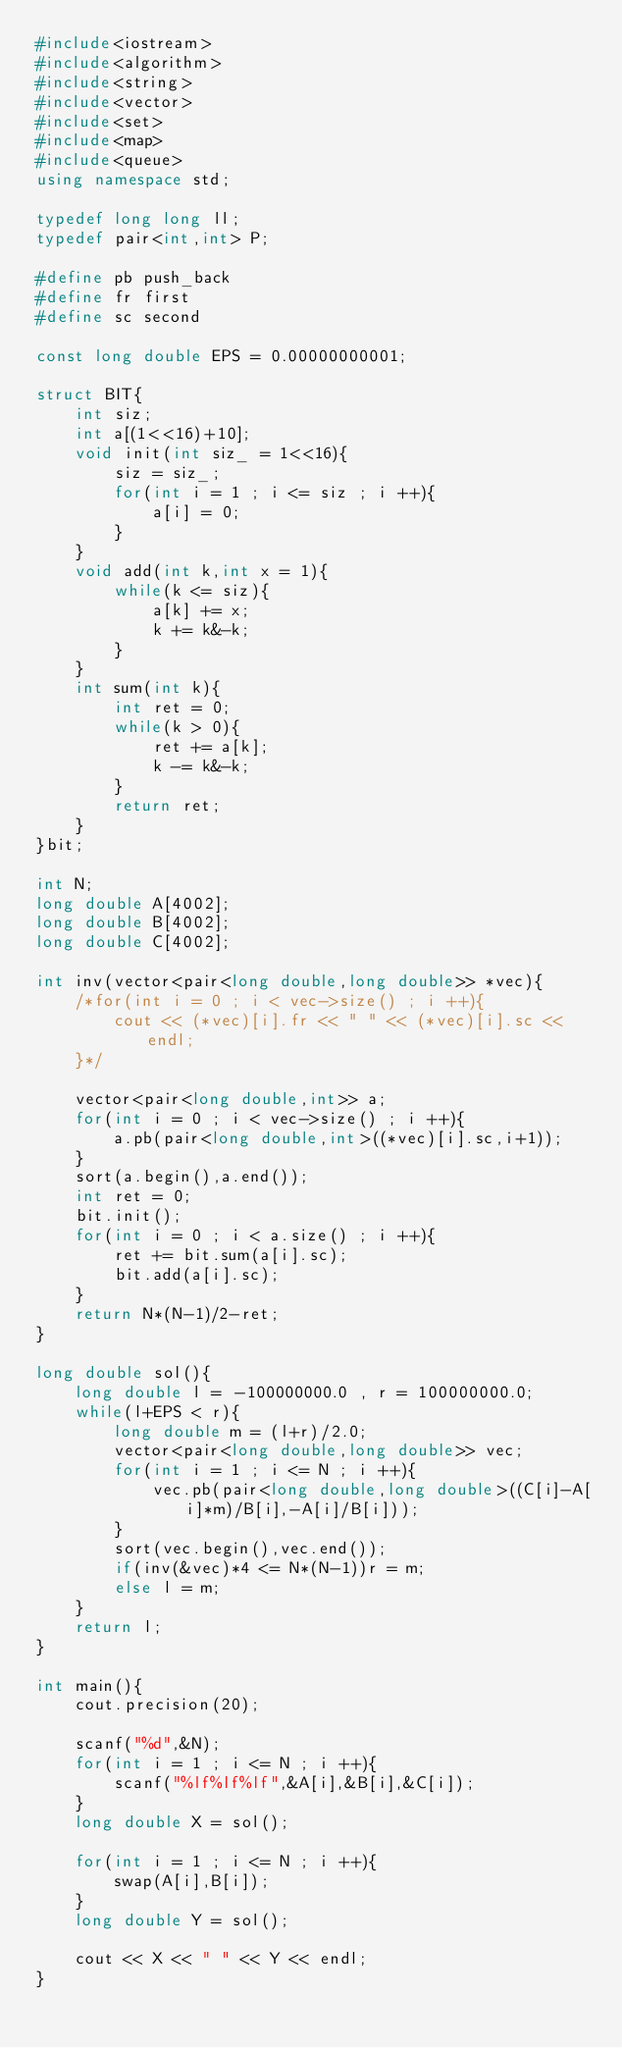<code> <loc_0><loc_0><loc_500><loc_500><_C++_>#include<iostream>
#include<algorithm>
#include<string>
#include<vector>
#include<set>
#include<map>
#include<queue>
using namespace std;

typedef long long ll;
typedef pair<int,int> P;

#define pb push_back
#define fr first
#define sc second

const long double EPS = 0.00000000001;

struct BIT{
	int siz;
	int a[(1<<16)+10];
	void init(int siz_ = 1<<16){
		siz = siz_;
		for(int i = 1 ; i <= siz ; i ++){
			a[i] = 0;
		}
	}
	void add(int k,int x = 1){
		while(k <= siz){
			a[k] += x;
			k += k&-k;
		}
	}
	int sum(int k){
		int ret = 0;
		while(k > 0){
			ret += a[k];
			k -= k&-k;
		}
		return ret;
	}
}bit;

int N;
long double A[4002];
long double B[4002];
long double C[4002];

int inv(vector<pair<long double,long double>> *vec){
	/*for(int i = 0 ; i < vec->size() ; i ++){
		cout << (*vec)[i].fr << " " << (*vec)[i].sc << endl;
	}*/
	
	vector<pair<long double,int>> a;
	for(int i = 0 ; i < vec->size() ; i ++){
		a.pb(pair<long double,int>((*vec)[i].sc,i+1));
	}
	sort(a.begin(),a.end());
	int ret = 0;
	bit.init();
	for(int i = 0 ; i < a.size() ; i ++){
		ret += bit.sum(a[i].sc);
		bit.add(a[i].sc);
	}
	return N*(N-1)/2-ret;
}

long double sol(){
	long double l = -100000000.0 , r = 100000000.0;
	while(l+EPS < r){
		long double m = (l+r)/2.0;
		vector<pair<long double,long double>> vec;
		for(int i = 1 ; i <= N ; i ++){
			vec.pb(pair<long double,long double>((C[i]-A[i]*m)/B[i],-A[i]/B[i]));
		}
		sort(vec.begin(),vec.end());
		if(inv(&vec)*4 <= N*(N-1))r = m;
		else l = m;
	}
	return l;
}

int main(){
	cout.precision(20);
	
	scanf("%d",&N);
	for(int i = 1 ; i <= N ; i ++){
		scanf("%lf%lf%lf",&A[i],&B[i],&C[i]);
	}
	long double X = sol();
	
	for(int i = 1 ; i <= N ; i ++){
		swap(A[i],B[i]);
	}
	long double Y = sol();
	
	cout << X << " " << Y << endl;
}

</code> 